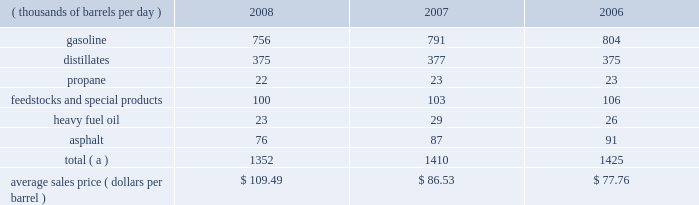The table sets forth our refined products sales by product group and our average sales price for each of the last three years .
Refined product sales ( thousands of barrels per day ) 2008 2007 2006 .
Total ( a ) 1352 1410 1425 average sales price ( dollars per barrel ) $ 109.49 $ 86.53 $ 77.76 ( a ) includes matching buy/sell volumes of 24 mbpd in 2006 .
On april 1 , 2006 , we changed our accounting for matching buy/sell arrangements as a result of a new accounting standard .
This change resulted in lower refined products sales volumes for 2008 , 2007 and the remainder of 2006 than would have been reported under our previous accounting practices .
See note 2 to the consolidated financial statements .
Gasoline and distillates 2013 we sell gasoline , gasoline blendstocks and no .
1 and no .
2 fuel oils ( including kerosene , jet fuel , diesel fuel and home heating oil ) to wholesale marketing customers in the midwest , upper great plains , gulf coast and southeastern regions of the united states .
We sold 47 percent of our gasoline volumes and 88 percent of our distillates volumes on a wholesale or spot market basis in 2008 .
The demand for gasoline is seasonal in many of our markets , with demand typically being at its highest levels during the summer months .
We have blended fuel ethanol into gasoline for over 15 years and began increasing our blending program in 2007 , in part due to federal regulations that require us to use specified volumes of renewable fuels .
We blended 57 mbpd of ethanol into gasoline in 2008 , 41 mbpd in 2007 and 35 mbpd in 2006 .
The future expansion or contraction of our ethanol blending program will be driven by the economics of the ethanol supply and by government regulations .
We sell reformulated gasoline , which is also blended with ethanol , in parts of our marketing territory , including : chicago , illinois ; louisville , kentucky ; northern kentucky ; milwaukee , wisconsin and hartford , illinois .
We also sell biodiesel-blended diesel in minnesota , illinois and kentucky .
In 2007 , we acquired a 35 percent interest in an entity which owns and operates a 110-million-gallon-per-year ethanol production facility in clymers , indiana .
We also own a 50 percent interest in an entity which owns a 110-million-gallon-per-year ethanol production facility in greenville , ohio .
The greenville plant began production in february 2008 .
Both of these facilities are managed by a co-owner .
Propane 2013 we produce propane at all seven of our refineries .
Propane is primarily used for home heating and cooking , as a feedstock within the petrochemical industry , for grain drying and as a fuel for trucks and other vehicles .
Our propane sales are typically split evenly between the home heating market and industrial consumers .
Feedstocks and special products 2013 we are a producer and marketer of petrochemicals and specialty products .
Product availability varies by refinery and includes benzene , cumene , dilute naphthalene oil , molten maleic anhydride , molten sulfur , propylene , toluene and xylene .
We market propylene , cumene and sulfur domestically to customers in the chemical industry .
We sell maleic anhydride throughout the united states and canada .
We also have the capacity to produce 1400 tons per day of anode grade coke at our robinson refinery , which is used to make carbon anodes for the aluminum smelting industry , and 2700 tons per day of fuel grade coke at the garyville refinery , which is used for power generation and in miscellaneous industrial applications .
In september 2008 , we shut down our lubes facility in catlettsburg , kentucky , and sold from inventory through december 31 , 2008 ; therefore , base oils , aromatic extracts and slack wax are no longer being produced and marketed .
In addition , we have recently discontinued production and sales of petroleum pitch and aliphatic solvents .
Heavy fuel oil 2013 we produce and market heavy oil , also known as fuel oil , residual fuel or slurry at all seven of our refineries .
Another product of crude oil , heavy oil is primarily used in the utility and ship bunkering ( fuel ) industries , though there are other more specialized uses of the product .
We also sell heavy fuel oil at our terminals in wellsville , ohio , and chattanooga , tennessee .
Asphalt 2013 we have refinery based asphalt production capacity of up to 102 mbpd .
We market asphalt through 33 owned or leased terminals throughout the midwest and southeast .
We have a broad customer base , including .
Based on average sales price , how much refined product sales revenue did mro achieve in 2008? 
Computations: (1352 * 109.49)
Answer: 148030.48. The table sets forth our refined products sales by product group and our average sales price for each of the last three years .
Refined product sales ( thousands of barrels per day ) 2008 2007 2006 .
Total ( a ) 1352 1410 1425 average sales price ( dollars per barrel ) $ 109.49 $ 86.53 $ 77.76 ( a ) includes matching buy/sell volumes of 24 mbpd in 2006 .
On april 1 , 2006 , we changed our accounting for matching buy/sell arrangements as a result of a new accounting standard .
This change resulted in lower refined products sales volumes for 2008 , 2007 and the remainder of 2006 than would have been reported under our previous accounting practices .
See note 2 to the consolidated financial statements .
Gasoline and distillates 2013 we sell gasoline , gasoline blendstocks and no .
1 and no .
2 fuel oils ( including kerosene , jet fuel , diesel fuel and home heating oil ) to wholesale marketing customers in the midwest , upper great plains , gulf coast and southeastern regions of the united states .
We sold 47 percent of our gasoline volumes and 88 percent of our distillates volumes on a wholesale or spot market basis in 2008 .
The demand for gasoline is seasonal in many of our markets , with demand typically being at its highest levels during the summer months .
We have blended fuel ethanol into gasoline for over 15 years and began increasing our blending program in 2007 , in part due to federal regulations that require us to use specified volumes of renewable fuels .
We blended 57 mbpd of ethanol into gasoline in 2008 , 41 mbpd in 2007 and 35 mbpd in 2006 .
The future expansion or contraction of our ethanol blending program will be driven by the economics of the ethanol supply and by government regulations .
We sell reformulated gasoline , which is also blended with ethanol , in parts of our marketing territory , including : chicago , illinois ; louisville , kentucky ; northern kentucky ; milwaukee , wisconsin and hartford , illinois .
We also sell biodiesel-blended diesel in minnesota , illinois and kentucky .
In 2007 , we acquired a 35 percent interest in an entity which owns and operates a 110-million-gallon-per-year ethanol production facility in clymers , indiana .
We also own a 50 percent interest in an entity which owns a 110-million-gallon-per-year ethanol production facility in greenville , ohio .
The greenville plant began production in february 2008 .
Both of these facilities are managed by a co-owner .
Propane 2013 we produce propane at all seven of our refineries .
Propane is primarily used for home heating and cooking , as a feedstock within the petrochemical industry , for grain drying and as a fuel for trucks and other vehicles .
Our propane sales are typically split evenly between the home heating market and industrial consumers .
Feedstocks and special products 2013 we are a producer and marketer of petrochemicals and specialty products .
Product availability varies by refinery and includes benzene , cumene , dilute naphthalene oil , molten maleic anhydride , molten sulfur , propylene , toluene and xylene .
We market propylene , cumene and sulfur domestically to customers in the chemical industry .
We sell maleic anhydride throughout the united states and canada .
We also have the capacity to produce 1400 tons per day of anode grade coke at our robinson refinery , which is used to make carbon anodes for the aluminum smelting industry , and 2700 tons per day of fuel grade coke at the garyville refinery , which is used for power generation and in miscellaneous industrial applications .
In september 2008 , we shut down our lubes facility in catlettsburg , kentucky , and sold from inventory through december 31 , 2008 ; therefore , base oils , aromatic extracts and slack wax are no longer being produced and marketed .
In addition , we have recently discontinued production and sales of petroleum pitch and aliphatic solvents .
Heavy fuel oil 2013 we produce and market heavy oil , also known as fuel oil , residual fuel or slurry at all seven of our refineries .
Another product of crude oil , heavy oil is primarily used in the utility and ship bunkering ( fuel ) industries , though there are other more specialized uses of the product .
We also sell heavy fuel oil at our terminals in wellsville , ohio , and chattanooga , tennessee .
Asphalt 2013 we have refinery based asphalt production capacity of up to 102 mbpd .
We market asphalt through 33 owned or leased terminals throughout the midwest and southeast .
We have a broad customer base , including .
What was the increase of blended ethanol into gasoline in 2008 from 2007 , in mmboe? 
Computations: (57 - 41)
Answer: 16.0. 